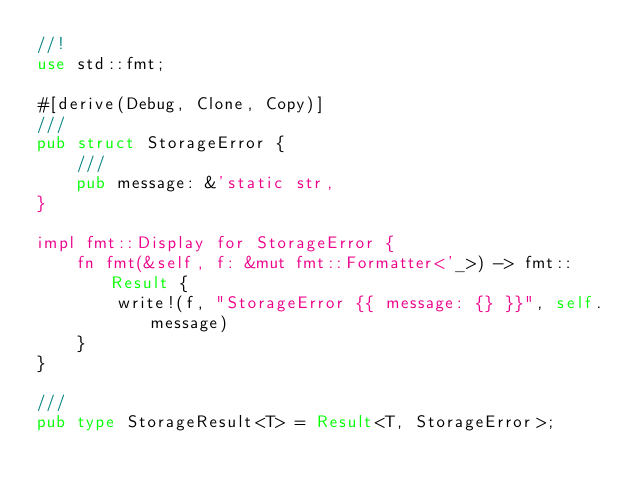Convert code to text. <code><loc_0><loc_0><loc_500><loc_500><_Rust_>//!
use std::fmt;

#[derive(Debug, Clone, Copy)]
///
pub struct StorageError {
    ///
    pub message: &'static str,
}

impl fmt::Display for StorageError {
    fn fmt(&self, f: &mut fmt::Formatter<'_>) -> fmt::Result {
        write!(f, "StorageError {{ message: {} }}", self.message)
    }
}

///
pub type StorageResult<T> = Result<T, StorageError>;
</code> 